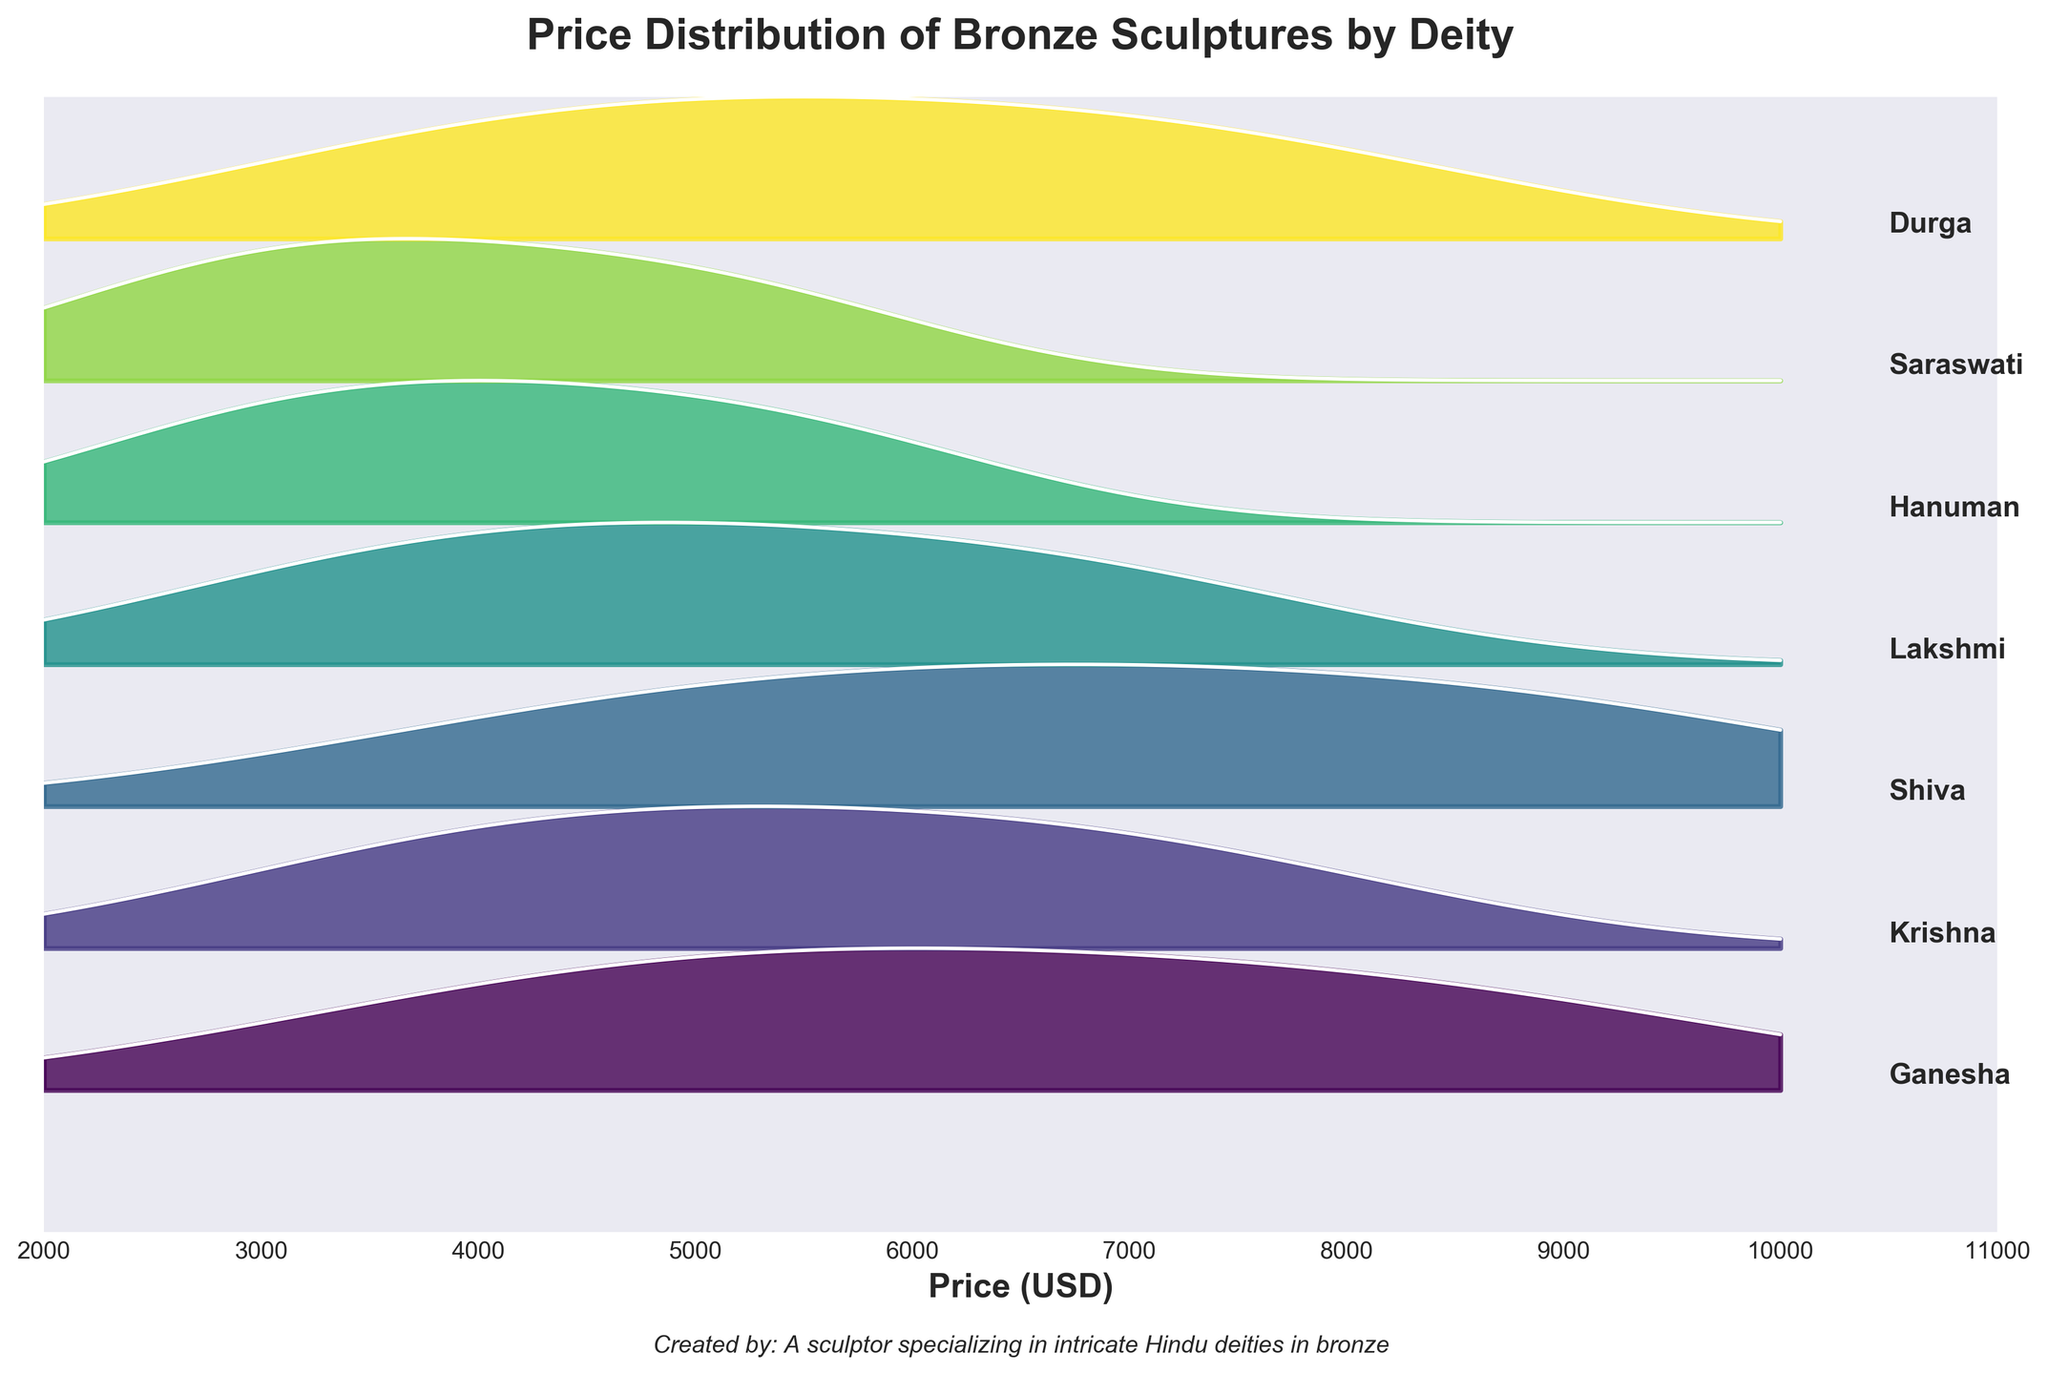What is the title of the figure? The title of the figure appears at the top, which reads "Price Distribution of Bronze Sculptures by Deity"
Answer: Price Distribution of Bronze Sculptures by Deity How many deities are represented in the figure? Each deity’s name is labeled on the right side of the ridgeline plot, with distinct colored ridgelines representing them. Counting these labels, we find there are six deities.
Answer: Six What is the price range displayed on the x-axis? The x-axis, which is labeled "Price (USD)," spans from 2000 to 11000 USD.
Answer: 2000 to 11000 USD Which deity has the highest price distribution range? Observing the widths of the ridgelines for each deity, Shiva's ridgeline spans from about 4700 to 9000 USD, the broadest range compared to others.
Answer: Shiva Which deity has the lowest price distribution range? By looking at the narrowly spread ridgelines, Saraswati’s price ranges approximately from 2700 to 5200 USD, indicating the lowest spread.
Answer: Saraswati What is the mean price of sculptures for Ganesha? Ganesha has three price points: 8500, 6200, and 4300 USD. The mean can be calculated as (8500 + 6200 + 4300) / 3 = 6300 USD.
Answer: 6300 USD Compare the price distribution of Shiva and Hanuman. Which one has generally higher prices? Shiva has prices ranging roughly from 4700 to 9000 USD, whereas Hanuman ranges from about 2900 to 5500 USD. Shiva’s prices are generally higher.
Answer: Shiva What can you infer about the popularity level and price range of the deities? By analyzing the color and labels, deities with "High" popularity (like Ganesha and Shiva) show a wider and generally higher price distribution compared to deities with "Low" popularity (like Saraswati and Hanuman). Higher popularity correlates with higher prices.
Answer: Higher popularity correlates with higher prices Which deities have a medium level of popularity, and what are their price ranges? Krishna, Lakshmi, and Durga are labeled "Medium" for popularity. Their ridgelines show Krishna’s prices range from 3800 to 7200 USD, Lakshmi’s from 3500 to 6800 USD, and Durga’s from 3900 to 7500 USD.
Answer: Krishna: 3800-7200 USD, Lakshmi: 3500-6800 USD, Durga: 3900-7500 USD 